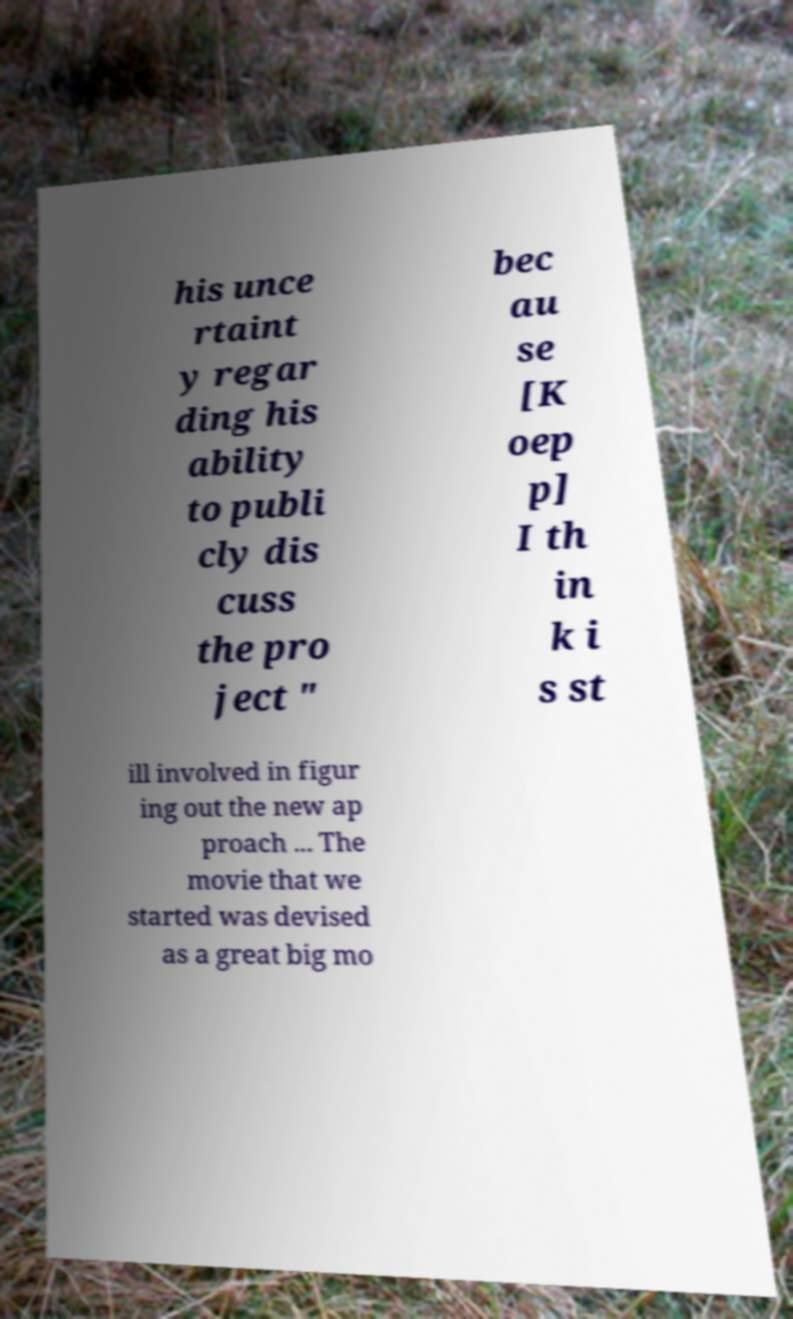What messages or text are displayed in this image? I need them in a readable, typed format. his unce rtaint y regar ding his ability to publi cly dis cuss the pro ject " bec au se [K oep p] I th in k i s st ill involved in figur ing out the new ap proach ... The movie that we started was devised as a great big mo 